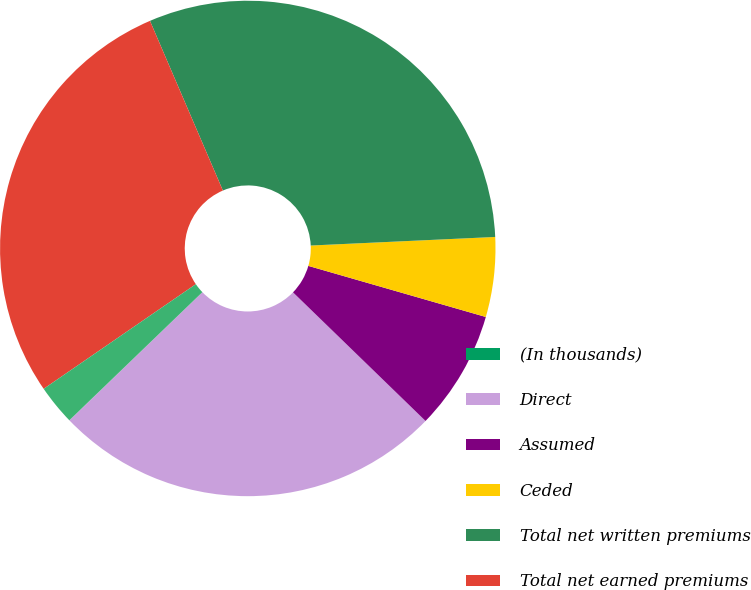Convert chart to OTSL. <chart><loc_0><loc_0><loc_500><loc_500><pie_chart><fcel>(In thousands)<fcel>Direct<fcel>Assumed<fcel>Ceded<fcel>Total net written premiums<fcel>Total net earned premiums<fcel>Ceded losses incurred<nl><fcel>0.01%<fcel>25.53%<fcel>7.8%<fcel>5.2%<fcel>30.72%<fcel>28.13%<fcel>2.61%<nl></chart> 